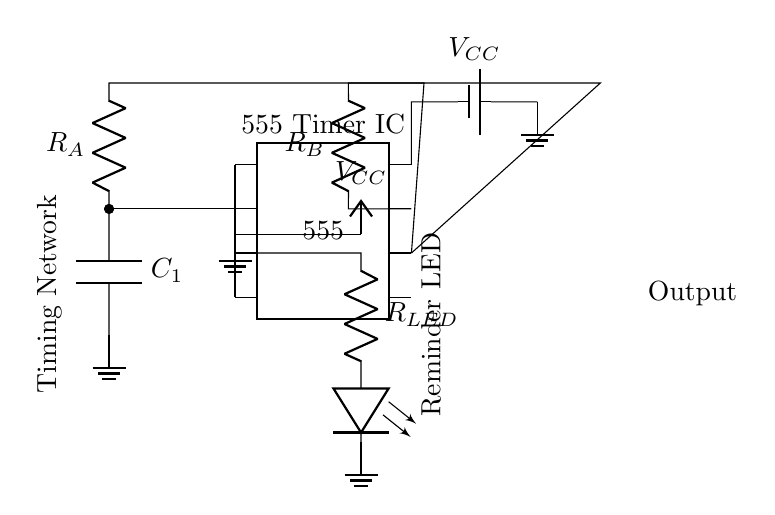what is the component at the center of the circuit? The component in the center is the 555 Timer IC, which is used for timing applications in circuits.
Answer: 555 Timer IC what is the purpose of the resistor labeled R_A? R_A is part of the timing network that influences the charge time of the capacitor. It sets the frequency and duration of the timer output.
Answer: Timing how is the LED activated in this circuit? The output pin of the 555 Timer IC connects to a resistor and then to the LED, allowing current to flow through the LED when the timer output is high, thereby activating the LED.
Answer: Current flow what is the voltage supplied to the circuit? The voltage supplied to this circuit is marked as V_CC, which is typically 5 volts for low power applications like timers.
Answer: 5 volts how does the capacitor influence the timer duration? The capacitor, labeled C_1, charges and discharges through the resistors R_A and R_B, which together determine the timing interval; longer capacitance increases the delay.
Answer: Controls timing what happens if R_B is increased? Increasing R_B will extend the discharging time of the capacitor, leading to a longer duration before the LED turns off. This change affects the overall timing of the circuit.
Answer: Longer duration what type of circuit is this? This circuit is a timer circuit designed for applications such as medication reminders, utilizing the 555 Timer IC for accurate timing intervals.
Answer: Timer circuit 